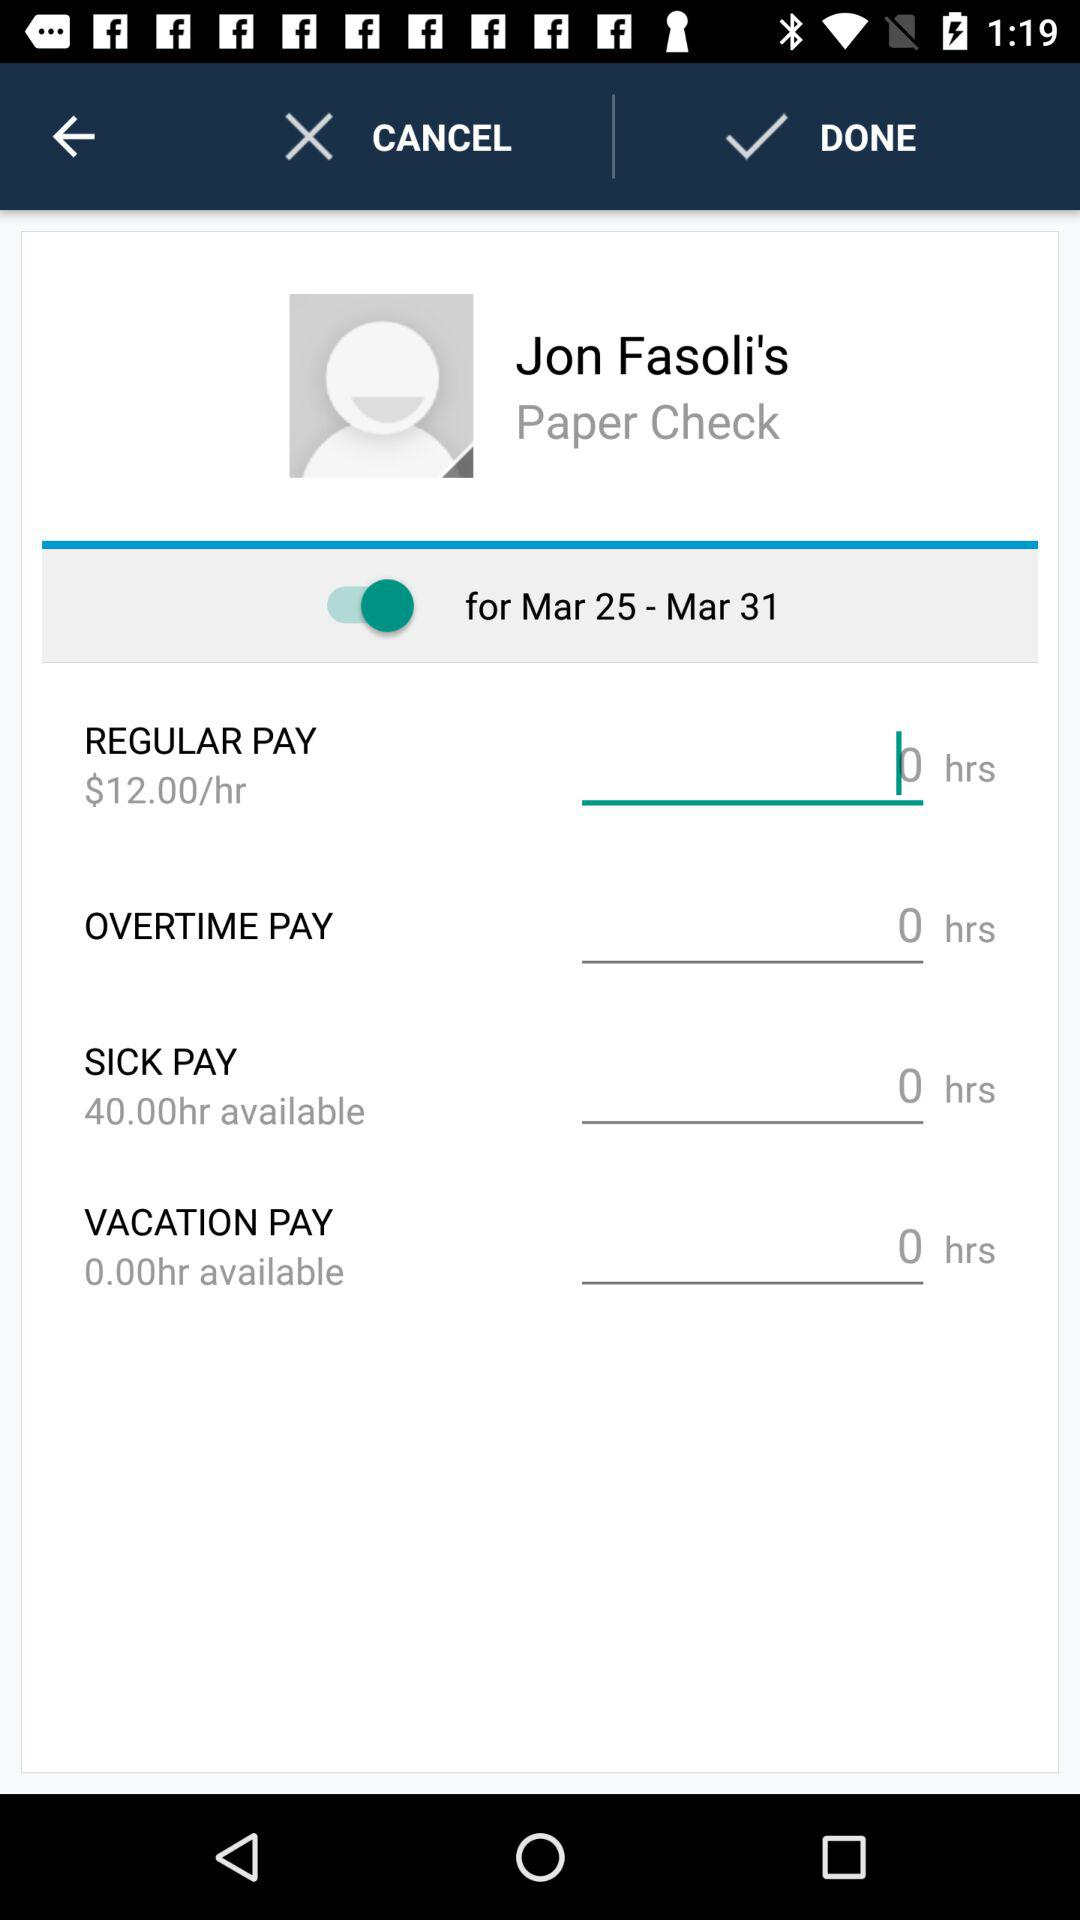For which date is the data shown? The dates for which the data is shown are from March 25 to March 31. 